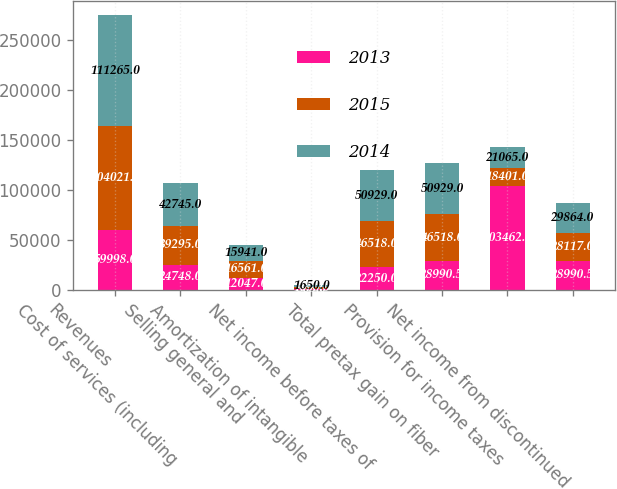Convert chart to OTSL. <chart><loc_0><loc_0><loc_500><loc_500><stacked_bar_chart><ecel><fcel>Revenues<fcel>Cost of services (including<fcel>Selling general and<fcel>Amortization of intangible<fcel>Net income before taxes of<fcel>Total pretax gain on fiber<fcel>Provision for income taxes<fcel>Net income from discontinued<nl><fcel>2013<fcel>59998<fcel>24748<fcel>12047<fcel>963<fcel>22250<fcel>28990.5<fcel>103462<fcel>28990.5<nl><fcel>2015<fcel>104021<fcel>39295<fcel>16561<fcel>1650<fcel>46518<fcel>46518<fcel>18401<fcel>28117<nl><fcel>2014<fcel>111265<fcel>42745<fcel>15941<fcel>1650<fcel>50929<fcel>50929<fcel>21065<fcel>29864<nl></chart> 